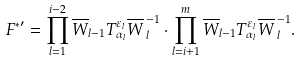<formula> <loc_0><loc_0><loc_500><loc_500>{ F ^ { * } } ^ { \prime } = \prod ^ { i - 2 } _ { l = 1 } \overline { W } _ { l - 1 } T ^ { \varepsilon _ { l } } _ { \alpha _ { l } } { \overline { W } \, } ^ { - 1 } _ { l } \cdot \prod ^ { m } _ { l = i + 1 } \overline { W } _ { l - 1 } T ^ { \varepsilon _ { l } } _ { \alpha _ { l } } { \overline { W } \, } ^ { - 1 } _ { l } .</formula> 